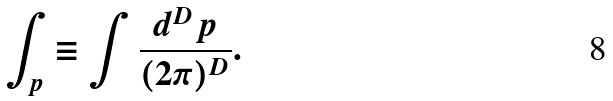Convert formula to latex. <formula><loc_0><loc_0><loc_500><loc_500>\int _ { p } \equiv \int \frac { d ^ { D } p } { ( 2 \pi ) ^ { D } } .</formula> 